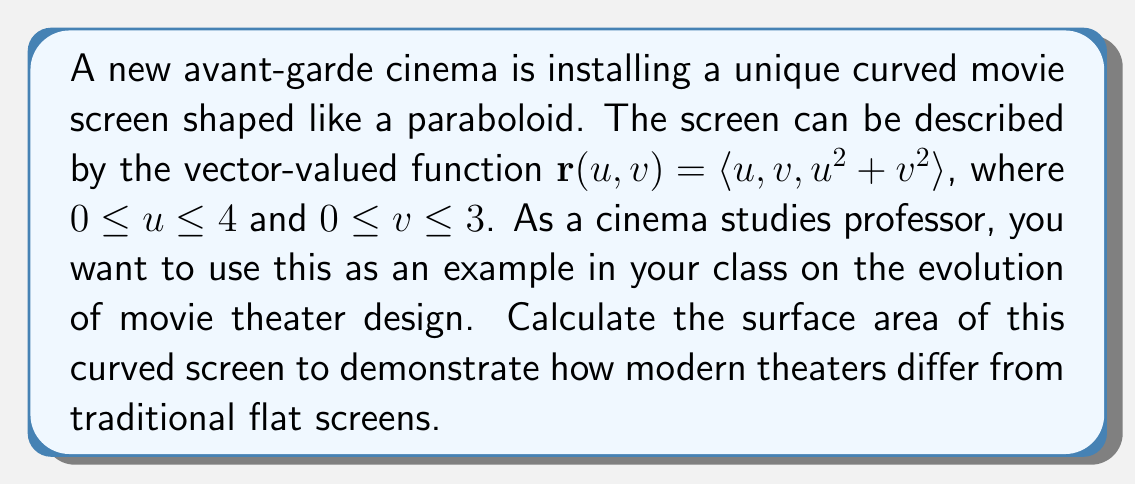Can you answer this question? To calculate the surface area of the curved screen, we need to use a surface integral. The steps are as follows:

1) First, we need to find the partial derivatives of $\mathbf{r}$ with respect to $u$ and $v$:

   $\mathbf{r}_u = \langle 1, 0, 2u \rangle$
   $\mathbf{r}_v = \langle 0, 1, 2v \rangle$

2) Next, we calculate the cross product of these partial derivatives:

   $\mathbf{r}_u \times \mathbf{r}_v = \langle 1, 0, 2u \rangle \times \langle 0, 1, 2v \rangle$
                                    $= \langle 2u, 2v, 1 \rangle$

3) The magnitude of this cross product is:

   $\|\mathbf{r}_u \times \mathbf{r}_v\| = \sqrt{(2u)^2 + (2v)^2 + 1^2} = \sqrt{4u^2 + 4v^2 + 1}$

4) The surface area is given by the double integral:

   $SA = \int\int_S \|\mathbf{r}_u \times \mathbf{r}_v\| \, dA$

   Where $S$ is the surface of the paraboloid.

5) Substituting the limits and the magnitude we found:

   $SA = \int_0^3 \int_0^4 \sqrt{4u^2 + 4v^2 + 1} \, du \, dv$

6) This integral cannot be evaluated analytically, so we need to use numerical methods to approximate the result. Using a computer algebra system or numerical integration software, we can evaluate this integral.

The result of this numerical integration is approximately 27.9431 square units.
Answer: The surface area of the curved movie screen is approximately 27.9431 square units. 